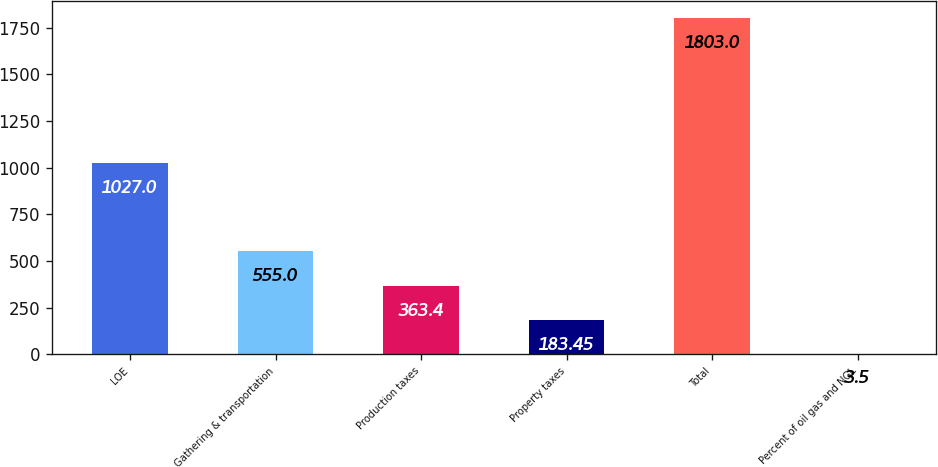<chart> <loc_0><loc_0><loc_500><loc_500><bar_chart><fcel>LOE<fcel>Gathering & transportation<fcel>Production taxes<fcel>Property taxes<fcel>Total<fcel>Percent of oil gas and NGL<nl><fcel>1027<fcel>555<fcel>363.4<fcel>183.45<fcel>1803<fcel>3.5<nl></chart> 